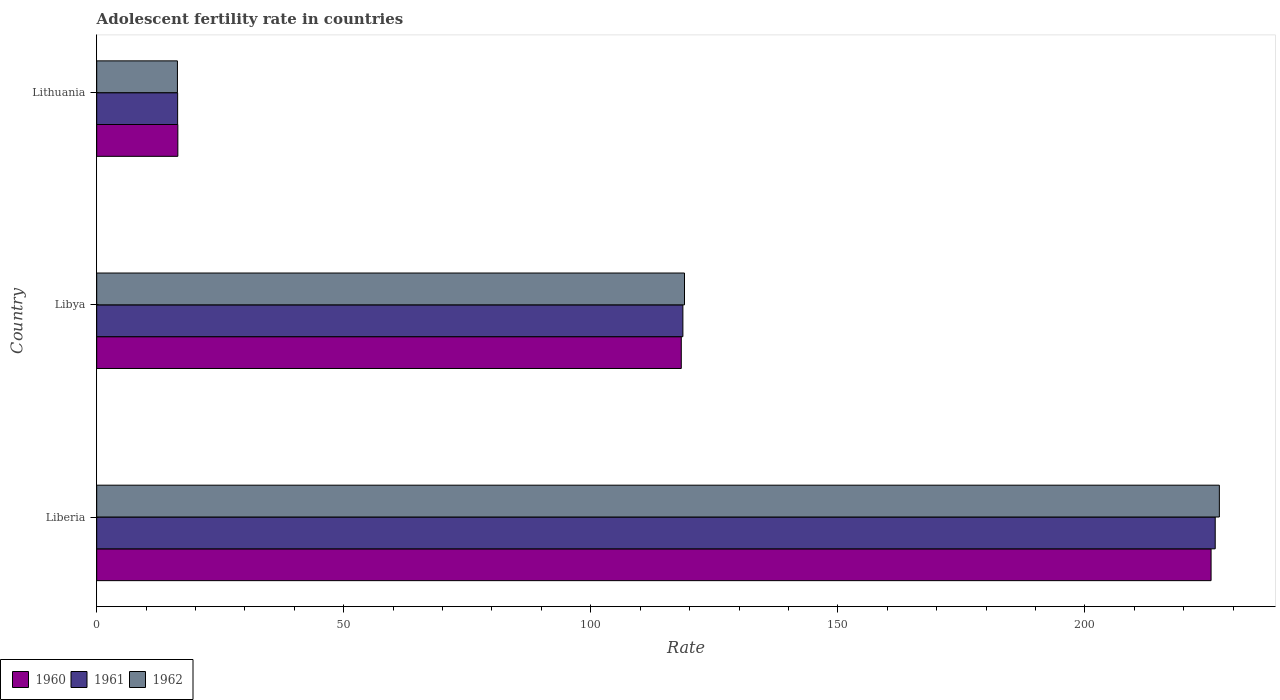How many different coloured bars are there?
Your response must be concise. 3. Are the number of bars on each tick of the Y-axis equal?
Make the answer very short. Yes. How many bars are there on the 2nd tick from the bottom?
Make the answer very short. 3. What is the label of the 1st group of bars from the top?
Ensure brevity in your answer.  Lithuania. In how many cases, is the number of bars for a given country not equal to the number of legend labels?
Ensure brevity in your answer.  0. What is the adolescent fertility rate in 1960 in Lithuania?
Your answer should be compact. 16.42. Across all countries, what is the maximum adolescent fertility rate in 1962?
Offer a very short reply. 227.21. Across all countries, what is the minimum adolescent fertility rate in 1960?
Offer a terse response. 16.42. In which country was the adolescent fertility rate in 1961 maximum?
Your answer should be compact. Liberia. In which country was the adolescent fertility rate in 1960 minimum?
Offer a terse response. Lithuania. What is the total adolescent fertility rate in 1960 in the graph?
Ensure brevity in your answer.  360.27. What is the difference between the adolescent fertility rate in 1962 in Liberia and that in Lithuania?
Make the answer very short. 210.87. What is the difference between the adolescent fertility rate in 1960 in Libya and the adolescent fertility rate in 1962 in Lithuania?
Make the answer very short. 101.97. What is the average adolescent fertility rate in 1960 per country?
Offer a very short reply. 120.09. What is the difference between the adolescent fertility rate in 1960 and adolescent fertility rate in 1961 in Liberia?
Keep it short and to the point. -0.84. In how many countries, is the adolescent fertility rate in 1960 greater than 220 ?
Provide a succinct answer. 1. What is the ratio of the adolescent fertility rate in 1961 in Liberia to that in Lithuania?
Make the answer very short. 13.82. Is the adolescent fertility rate in 1962 in Liberia less than that in Lithuania?
Your answer should be compact. No. Is the difference between the adolescent fertility rate in 1960 in Libya and Lithuania greater than the difference between the adolescent fertility rate in 1961 in Libya and Lithuania?
Ensure brevity in your answer.  No. What is the difference between the highest and the second highest adolescent fertility rate in 1960?
Your answer should be very brief. 107.22. What is the difference between the highest and the lowest adolescent fertility rate in 1960?
Give a very brief answer. 209.12. Is the sum of the adolescent fertility rate in 1960 in Libya and Lithuania greater than the maximum adolescent fertility rate in 1961 across all countries?
Provide a short and direct response. No. What does the 1st bar from the top in Libya represents?
Give a very brief answer. 1962. What does the 2nd bar from the bottom in Liberia represents?
Keep it short and to the point. 1961. Are all the bars in the graph horizontal?
Keep it short and to the point. Yes. What is the difference between two consecutive major ticks on the X-axis?
Ensure brevity in your answer.  50. Does the graph contain grids?
Provide a short and direct response. No. How many legend labels are there?
Ensure brevity in your answer.  3. How are the legend labels stacked?
Make the answer very short. Horizontal. What is the title of the graph?
Make the answer very short. Adolescent fertility rate in countries. What is the label or title of the X-axis?
Keep it short and to the point. Rate. What is the label or title of the Y-axis?
Ensure brevity in your answer.  Country. What is the Rate of 1960 in Liberia?
Provide a succinct answer. 225.53. What is the Rate of 1961 in Liberia?
Your response must be concise. 226.37. What is the Rate of 1962 in Liberia?
Make the answer very short. 227.21. What is the Rate in 1960 in Libya?
Provide a succinct answer. 118.31. What is the Rate of 1961 in Libya?
Offer a terse response. 118.64. What is the Rate of 1962 in Libya?
Make the answer very short. 118.96. What is the Rate in 1960 in Lithuania?
Give a very brief answer. 16.42. What is the Rate in 1961 in Lithuania?
Your answer should be compact. 16.38. What is the Rate in 1962 in Lithuania?
Provide a short and direct response. 16.34. Across all countries, what is the maximum Rate of 1960?
Offer a terse response. 225.53. Across all countries, what is the maximum Rate of 1961?
Your response must be concise. 226.37. Across all countries, what is the maximum Rate of 1962?
Your answer should be compact. 227.21. Across all countries, what is the minimum Rate in 1960?
Provide a succinct answer. 16.42. Across all countries, what is the minimum Rate in 1961?
Ensure brevity in your answer.  16.38. Across all countries, what is the minimum Rate of 1962?
Offer a very short reply. 16.34. What is the total Rate in 1960 in the graph?
Provide a short and direct response. 360.26. What is the total Rate in 1961 in the graph?
Offer a terse response. 361.39. What is the total Rate of 1962 in the graph?
Offer a terse response. 362.51. What is the difference between the Rate of 1960 in Liberia and that in Libya?
Keep it short and to the point. 107.22. What is the difference between the Rate of 1961 in Liberia and that in Libya?
Provide a succinct answer. 107.74. What is the difference between the Rate of 1962 in Liberia and that in Libya?
Provide a succinct answer. 108.25. What is the difference between the Rate of 1960 in Liberia and that in Lithuania?
Keep it short and to the point. 209.12. What is the difference between the Rate in 1961 in Liberia and that in Lithuania?
Offer a terse response. 209.99. What is the difference between the Rate of 1962 in Liberia and that in Lithuania?
Give a very brief answer. 210.87. What is the difference between the Rate of 1960 in Libya and that in Lithuania?
Your answer should be compact. 101.89. What is the difference between the Rate of 1961 in Libya and that in Lithuania?
Your response must be concise. 102.26. What is the difference between the Rate of 1962 in Libya and that in Lithuania?
Ensure brevity in your answer.  102.62. What is the difference between the Rate of 1960 in Liberia and the Rate of 1961 in Libya?
Give a very brief answer. 106.9. What is the difference between the Rate of 1960 in Liberia and the Rate of 1962 in Libya?
Keep it short and to the point. 106.57. What is the difference between the Rate in 1961 in Liberia and the Rate in 1962 in Libya?
Provide a short and direct response. 107.41. What is the difference between the Rate of 1960 in Liberia and the Rate of 1961 in Lithuania?
Give a very brief answer. 209.16. What is the difference between the Rate in 1960 in Liberia and the Rate in 1962 in Lithuania?
Offer a very short reply. 209.19. What is the difference between the Rate of 1961 in Liberia and the Rate of 1962 in Lithuania?
Make the answer very short. 210.03. What is the difference between the Rate of 1960 in Libya and the Rate of 1961 in Lithuania?
Give a very brief answer. 101.93. What is the difference between the Rate in 1960 in Libya and the Rate in 1962 in Lithuania?
Provide a succinct answer. 101.97. What is the difference between the Rate in 1961 in Libya and the Rate in 1962 in Lithuania?
Give a very brief answer. 102.3. What is the average Rate in 1960 per country?
Make the answer very short. 120.09. What is the average Rate of 1961 per country?
Offer a very short reply. 120.46. What is the average Rate of 1962 per country?
Provide a short and direct response. 120.84. What is the difference between the Rate in 1960 and Rate in 1961 in Liberia?
Make the answer very short. -0.84. What is the difference between the Rate in 1960 and Rate in 1962 in Liberia?
Give a very brief answer. -1.68. What is the difference between the Rate of 1961 and Rate of 1962 in Liberia?
Offer a very short reply. -0.84. What is the difference between the Rate in 1960 and Rate in 1961 in Libya?
Make the answer very short. -0.33. What is the difference between the Rate in 1960 and Rate in 1962 in Libya?
Your answer should be compact. -0.65. What is the difference between the Rate of 1961 and Rate of 1962 in Libya?
Give a very brief answer. -0.33. What is the difference between the Rate in 1961 and Rate in 1962 in Lithuania?
Your answer should be compact. 0.04. What is the ratio of the Rate in 1960 in Liberia to that in Libya?
Provide a short and direct response. 1.91. What is the ratio of the Rate of 1961 in Liberia to that in Libya?
Ensure brevity in your answer.  1.91. What is the ratio of the Rate in 1962 in Liberia to that in Libya?
Offer a very short reply. 1.91. What is the ratio of the Rate of 1960 in Liberia to that in Lithuania?
Your answer should be compact. 13.74. What is the ratio of the Rate of 1961 in Liberia to that in Lithuania?
Your answer should be very brief. 13.82. What is the ratio of the Rate in 1962 in Liberia to that in Lithuania?
Keep it short and to the point. 13.91. What is the ratio of the Rate in 1960 in Libya to that in Lithuania?
Make the answer very short. 7.21. What is the ratio of the Rate of 1961 in Libya to that in Lithuania?
Offer a terse response. 7.24. What is the ratio of the Rate in 1962 in Libya to that in Lithuania?
Provide a short and direct response. 7.28. What is the difference between the highest and the second highest Rate in 1960?
Provide a succinct answer. 107.22. What is the difference between the highest and the second highest Rate of 1961?
Ensure brevity in your answer.  107.74. What is the difference between the highest and the second highest Rate in 1962?
Provide a short and direct response. 108.25. What is the difference between the highest and the lowest Rate of 1960?
Your answer should be compact. 209.12. What is the difference between the highest and the lowest Rate in 1961?
Your response must be concise. 209.99. What is the difference between the highest and the lowest Rate of 1962?
Your answer should be very brief. 210.87. 